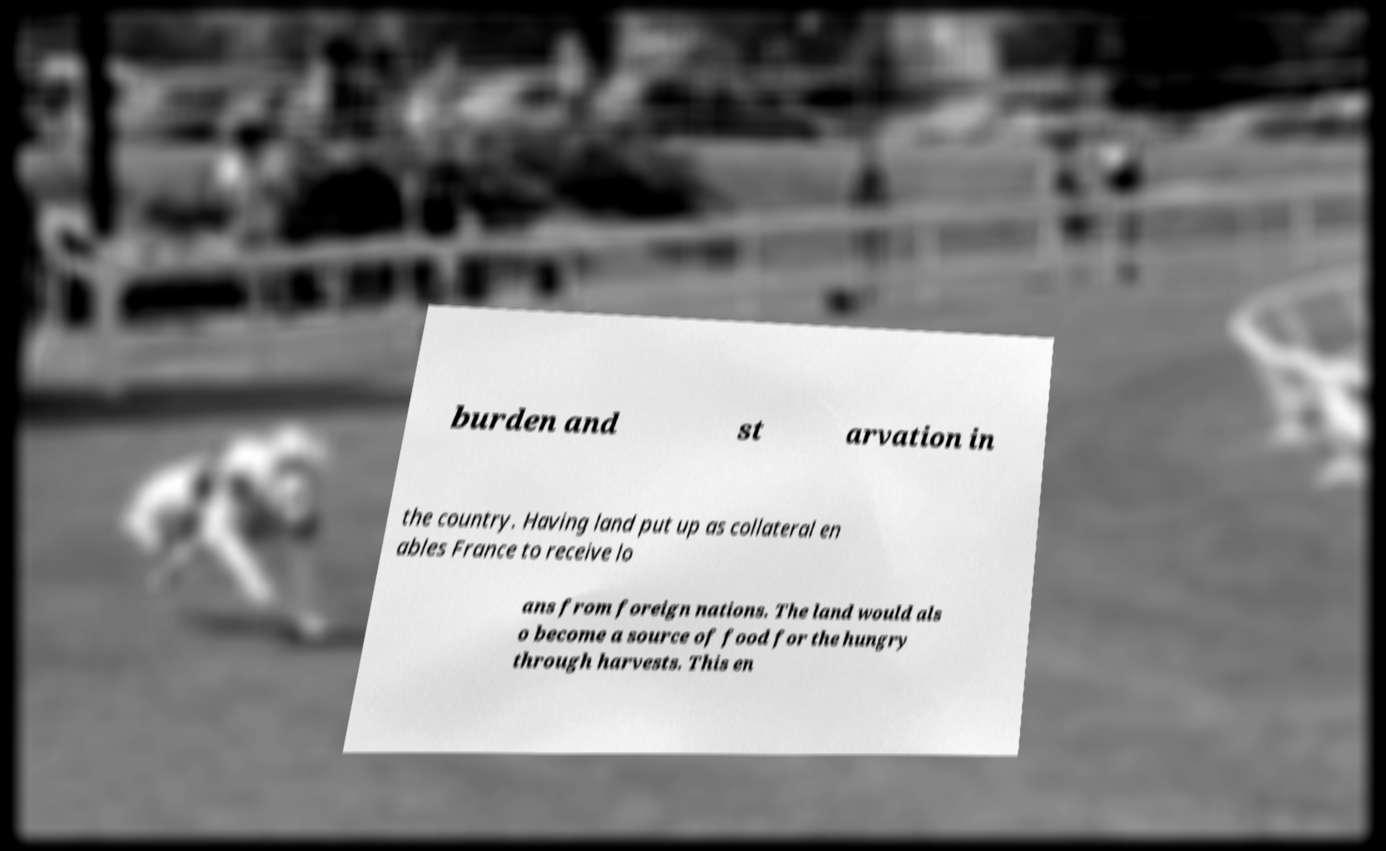For documentation purposes, I need the text within this image transcribed. Could you provide that? burden and st arvation in the country. Having land put up as collateral en ables France to receive lo ans from foreign nations. The land would als o become a source of food for the hungry through harvests. This en 